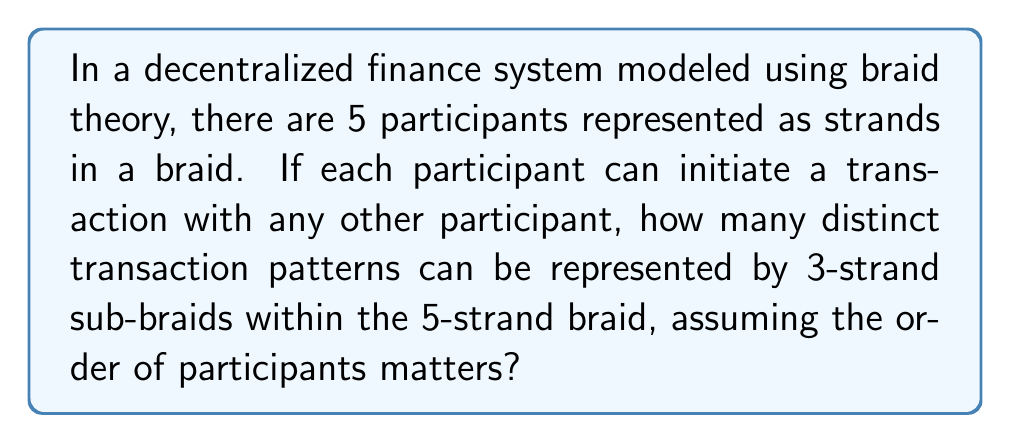Give your solution to this math problem. To solve this problem, we need to follow these steps:

1) First, we need to understand that we're looking for 3-strand sub-braids within a 5-strand braid. This is because each transaction involves 3 participants: the initiator, the receiver, and the validator.

2) The number of ways to choose 3 strands out of 5 is given by the combination formula:

   $$\binom{5}{3} = \frac{5!}{3!(5-3)!} = \frac{5 \cdot 4 \cdot 3}{3 \cdot 2 \cdot 1} = 10$$

3) However, the order of participants matters in this case. For each set of 3 strands, we need to consider all possible permutations. The number of permutations of 3 elements is:

   $$3! = 3 \cdot 2 \cdot 1 = 6$$

4) Therefore, for each set of 3 strands, we have 6 distinct transaction patterns.

5) The total number of distinct transaction patterns is thus:

   $$10 \cdot 6 = 60$$

This result shows the complexity that can arise in decentralized finance systems even with a relatively small number of participants, highlighting a potential drawback in terms of transaction pattern complexity and system analysis.
Answer: 60 